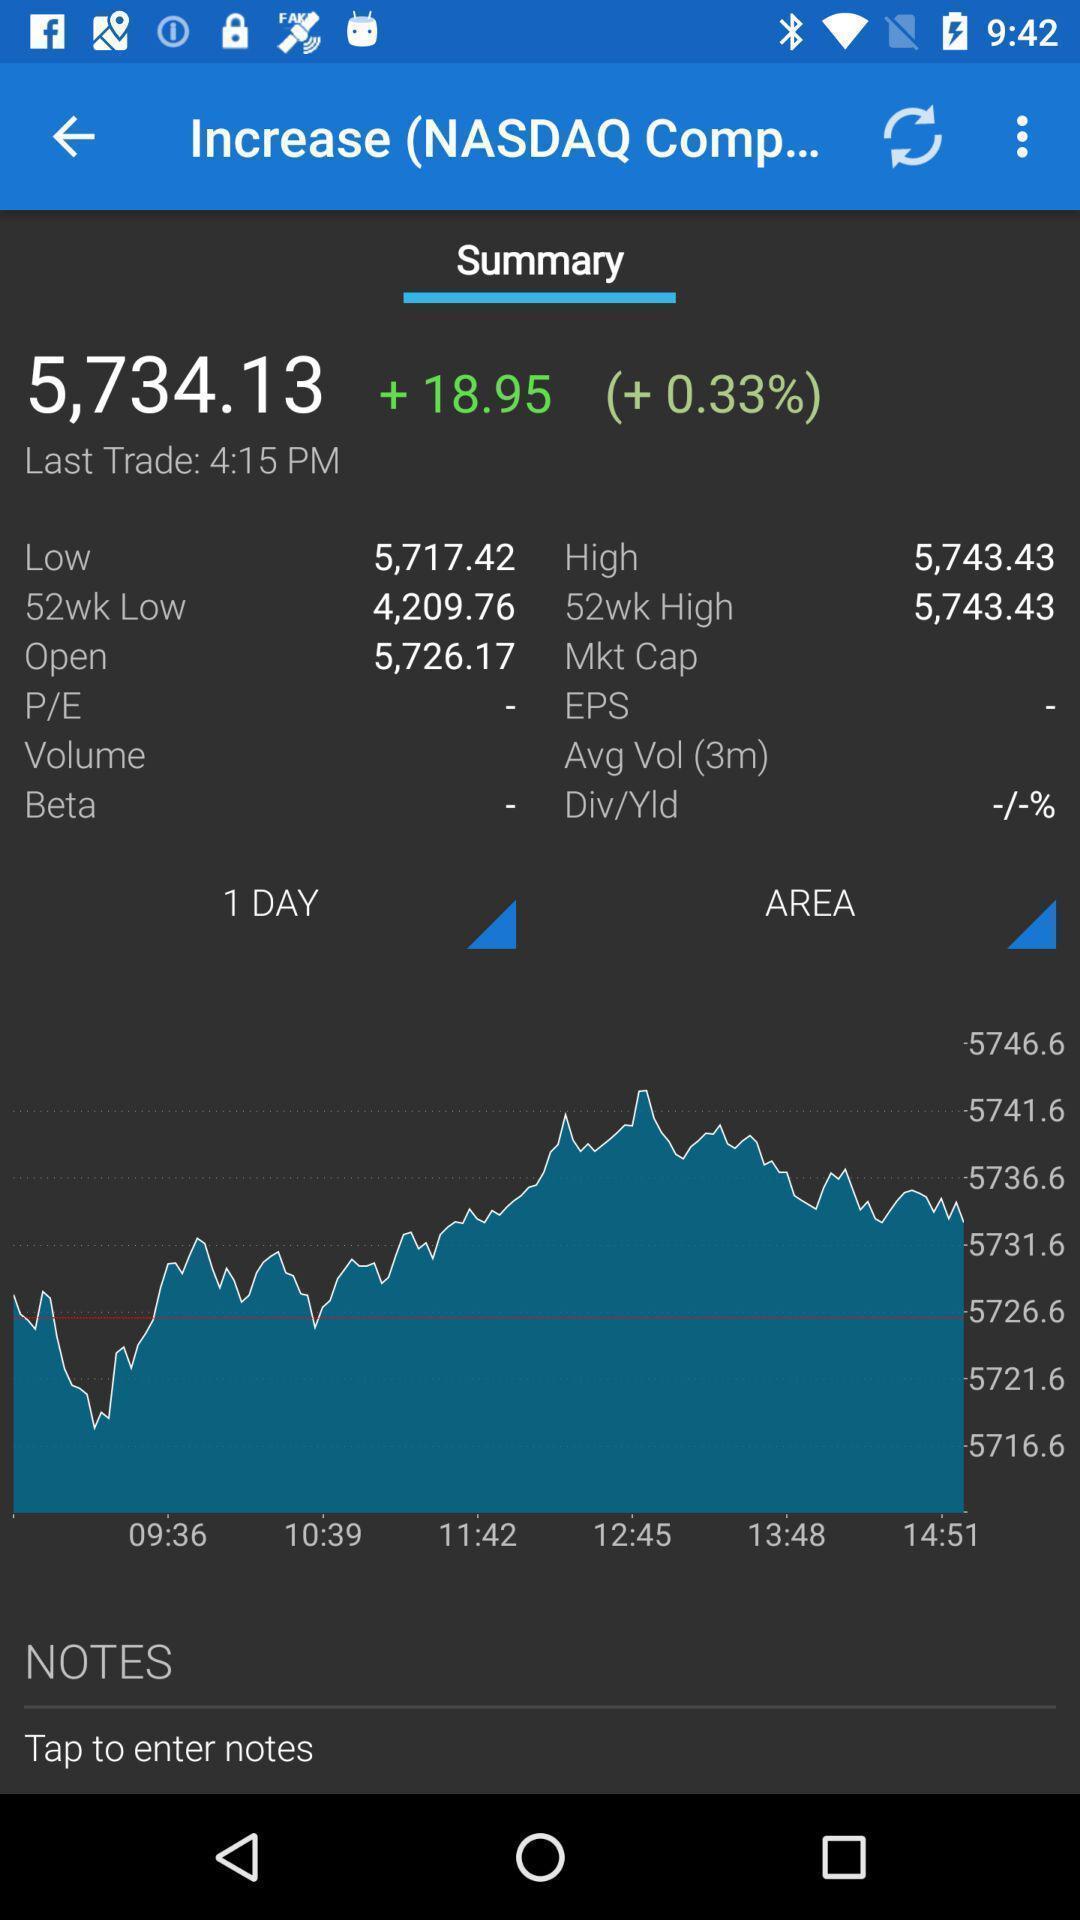Give me a narrative description of this picture. Page showing summary. 